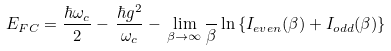Convert formula to latex. <formula><loc_0><loc_0><loc_500><loc_500>E _ { F C } = \frac { \hbar { \omega } _ { c } } { 2 } - \, \frac { \hbar { g } ^ { 2 } } { \omega _ { c } } - \, \lim _ { \beta \to \infty } \frac { } { \beta } \ln \left \{ I _ { e v e n } ( \beta ) + I _ { o d d } ( \beta ) \right \}</formula> 